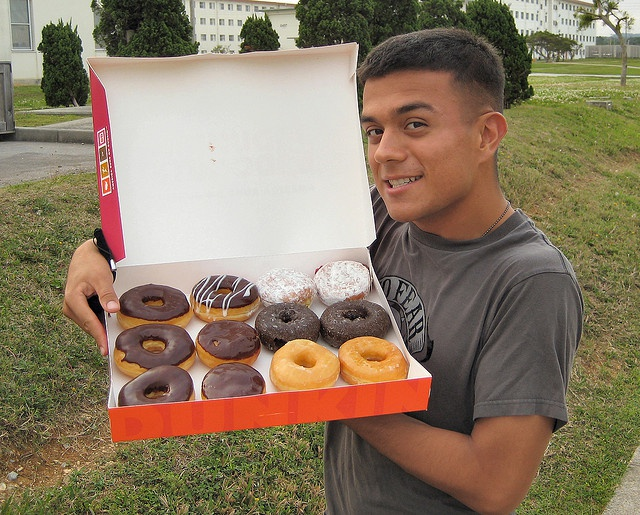Describe the objects in this image and their specific colors. I can see people in lightgray, gray, brown, and black tones, donut in lightgray, brown, maroon, gray, and olive tones, donut in lightgray, orange, and tan tones, donut in lightgray, orange, and red tones, and donut in lightgray, gray, black, and maroon tones in this image. 